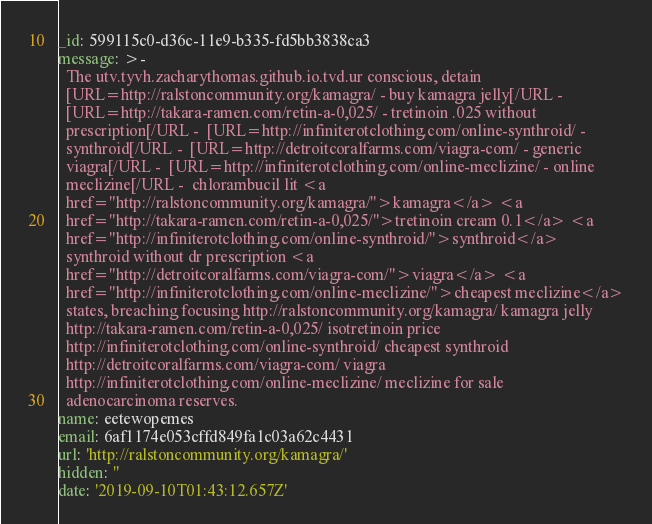<code> <loc_0><loc_0><loc_500><loc_500><_YAML_>_id: 599115c0-d36c-11e9-b335-fd5bb3838ca3
message: >-
  The utv.tyvh.zacharythomas.github.io.tvd.ur conscious, detain
  [URL=http://ralstoncommunity.org/kamagra/ - buy kamagra jelly[/URL - 
  [URL=http://takara-ramen.com/retin-a-0,025/ - tretinoin .025 without
  prescription[/URL -  [URL=http://infiniterotclothing.com/online-synthroid/ -
  synthroid[/URL -  [URL=http://detroitcoralfarms.com/viagra-com/ - generic
  viagra[/URL -  [URL=http://infiniterotclothing.com/online-meclizine/ - online
  meclizine[/URL -  chlorambucil lit <a
  href="http://ralstoncommunity.org/kamagra/">kamagra</a> <a
  href="http://takara-ramen.com/retin-a-0,025/">tretinoin cream 0.1</a> <a
  href="http://infiniterotclothing.com/online-synthroid/">synthroid</a>
  synthroid without dr prescription <a
  href="http://detroitcoralfarms.com/viagra-com/">viagra</a> <a
  href="http://infiniterotclothing.com/online-meclizine/">cheapest meclizine</a>
  states, breaching focusing http://ralstoncommunity.org/kamagra/ kamagra jelly
  http://takara-ramen.com/retin-a-0,025/ isotretinoin price
  http://infiniterotclothing.com/online-synthroid/ cheapest synthroid
  http://detroitcoralfarms.com/viagra-com/ viagra
  http://infiniterotclothing.com/online-meclizine/ meclizine for sale
  adenocarcinoma reserves.
name: eetewopemes
email: 6af1174e053cffd849fa1c03a62c4431
url: 'http://ralstoncommunity.org/kamagra/'
hidden: ''
date: '2019-09-10T01:43:12.657Z'
</code> 